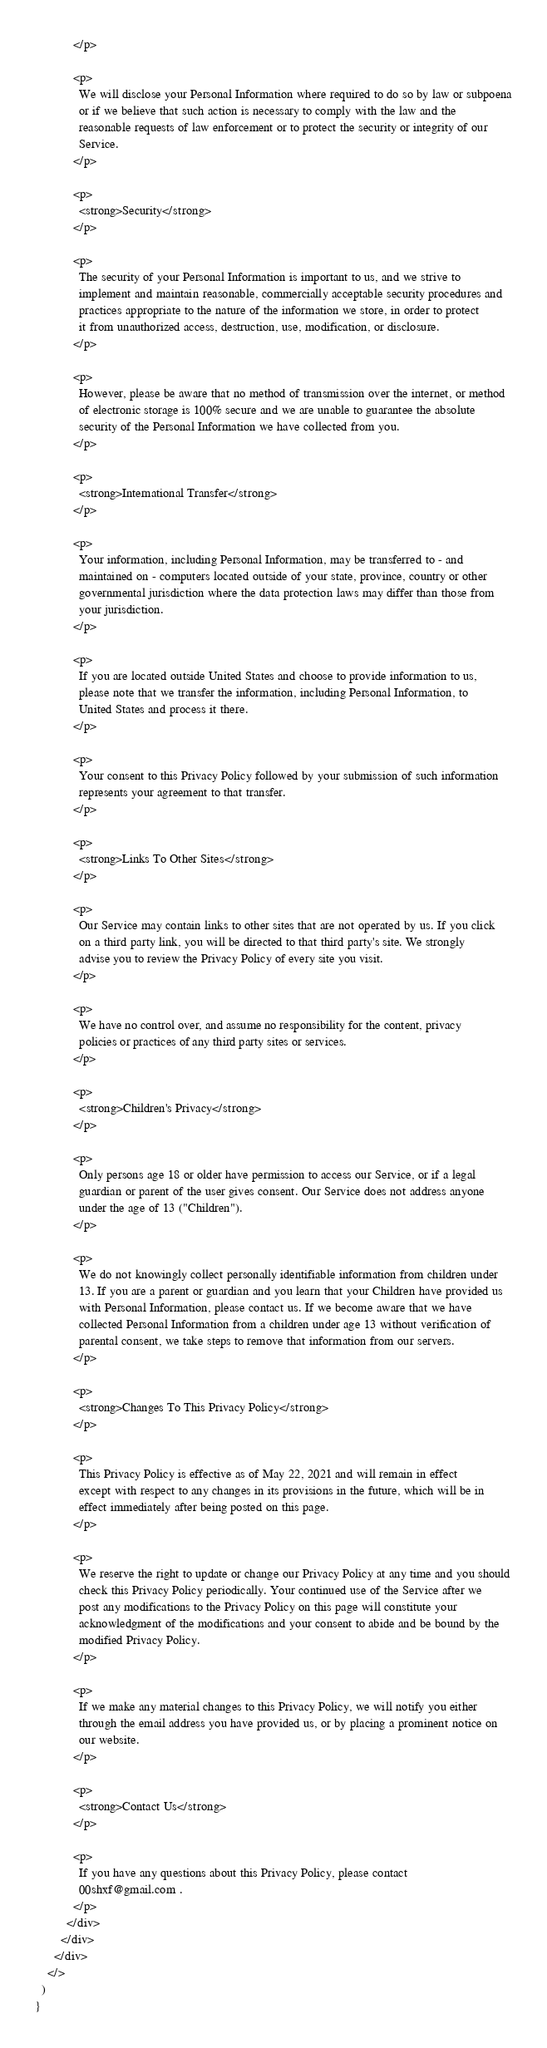Convert code to text. <code><loc_0><loc_0><loc_500><loc_500><_JavaScript_>            </p>

            <p>
              We will disclose your Personal Information where required to do so by law or subpoena
              or if we believe that such action is necessary to comply with the law and the
              reasonable requests of law enforcement or to protect the security or integrity of our
              Service.
            </p>

            <p>
              <strong>Security</strong>
            </p>

            <p>
              The security of your Personal Information is important to us, and we strive to
              implement and maintain reasonable, commercially acceptable security procedures and
              practices appropriate to the nature of the information we store, in order to protect
              it from unauthorized access, destruction, use, modification, or disclosure.
            </p>

            <p>
              However, please be aware that no method of transmission over the internet, or method
              of electronic storage is 100% secure and we are unable to guarantee the absolute
              security of the Personal Information we have collected from you.
            </p>

            <p>
              <strong>International Transfer</strong>
            </p>

            <p>
              Your information, including Personal Information, may be transferred to - and
              maintained on - computers located outside of your state, province, country or other
              governmental jurisdiction where the data protection laws may differ than those from
              your jurisdiction.
            </p>

            <p>
              If you are located outside United States and choose to provide information to us,
              please note that we transfer the information, including Personal Information, to
              United States and process it there.
            </p>

            <p>
              Your consent to this Privacy Policy followed by your submission of such information
              represents your agreement to that transfer.
            </p>

            <p>
              <strong>Links To Other Sites</strong>
            </p>

            <p>
              Our Service may contain links to other sites that are not operated by us. If you click
              on a third party link, you will be directed to that third party's site. We strongly
              advise you to review the Privacy Policy of every site you visit.
            </p>

            <p>
              We have no control over, and assume no responsibility for the content, privacy
              policies or practices of any third party sites or services.
            </p>

            <p>
              <strong>Children's Privacy</strong>
            </p>

            <p>
              Only persons age 18 or older have permission to access our Service, or if a legal
              guardian or parent of the user gives consent. Our Service does not address anyone
              under the age of 13 ("Children").
            </p>

            <p>
              We do not knowingly collect personally identifiable information from children under
              13. If you are a parent or guardian and you learn that your Children have provided us
              with Personal Information, please contact us. If we become aware that we have
              collected Personal Information from a children under age 13 without verification of
              parental consent, we take steps to remove that information from our servers.
            </p>

            <p>
              <strong>Changes To This Privacy Policy</strong>
            </p>

            <p>
              This Privacy Policy is effective as of May 22, 2021 and will remain in effect
              except with respect to any changes in its provisions in the future, which will be in
              effect immediately after being posted on this page.
            </p>

            <p>
              We reserve the right to update or change our Privacy Policy at any time and you should
              check this Privacy Policy periodically. Your continued use of the Service after we
              post any modifications to the Privacy Policy on this page will constitute your
              acknowledgment of the modifications and your consent to abide and be bound by the
              modified Privacy Policy.
            </p>

            <p>
              If we make any material changes to this Privacy Policy, we will notify you either
              through the email address you have provided us, or by placing a prominent notice on
              our website.
            </p>

            <p>
              <strong>Contact Us</strong>
            </p>

            <p>
              If you have any questions about this Privacy Policy, please contact
              00shxf@gmail.com .
            </p>
          </div>
        </div>
      </div>
    </>
  )
}
</code> 